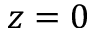<formula> <loc_0><loc_0><loc_500><loc_500>z = 0</formula> 